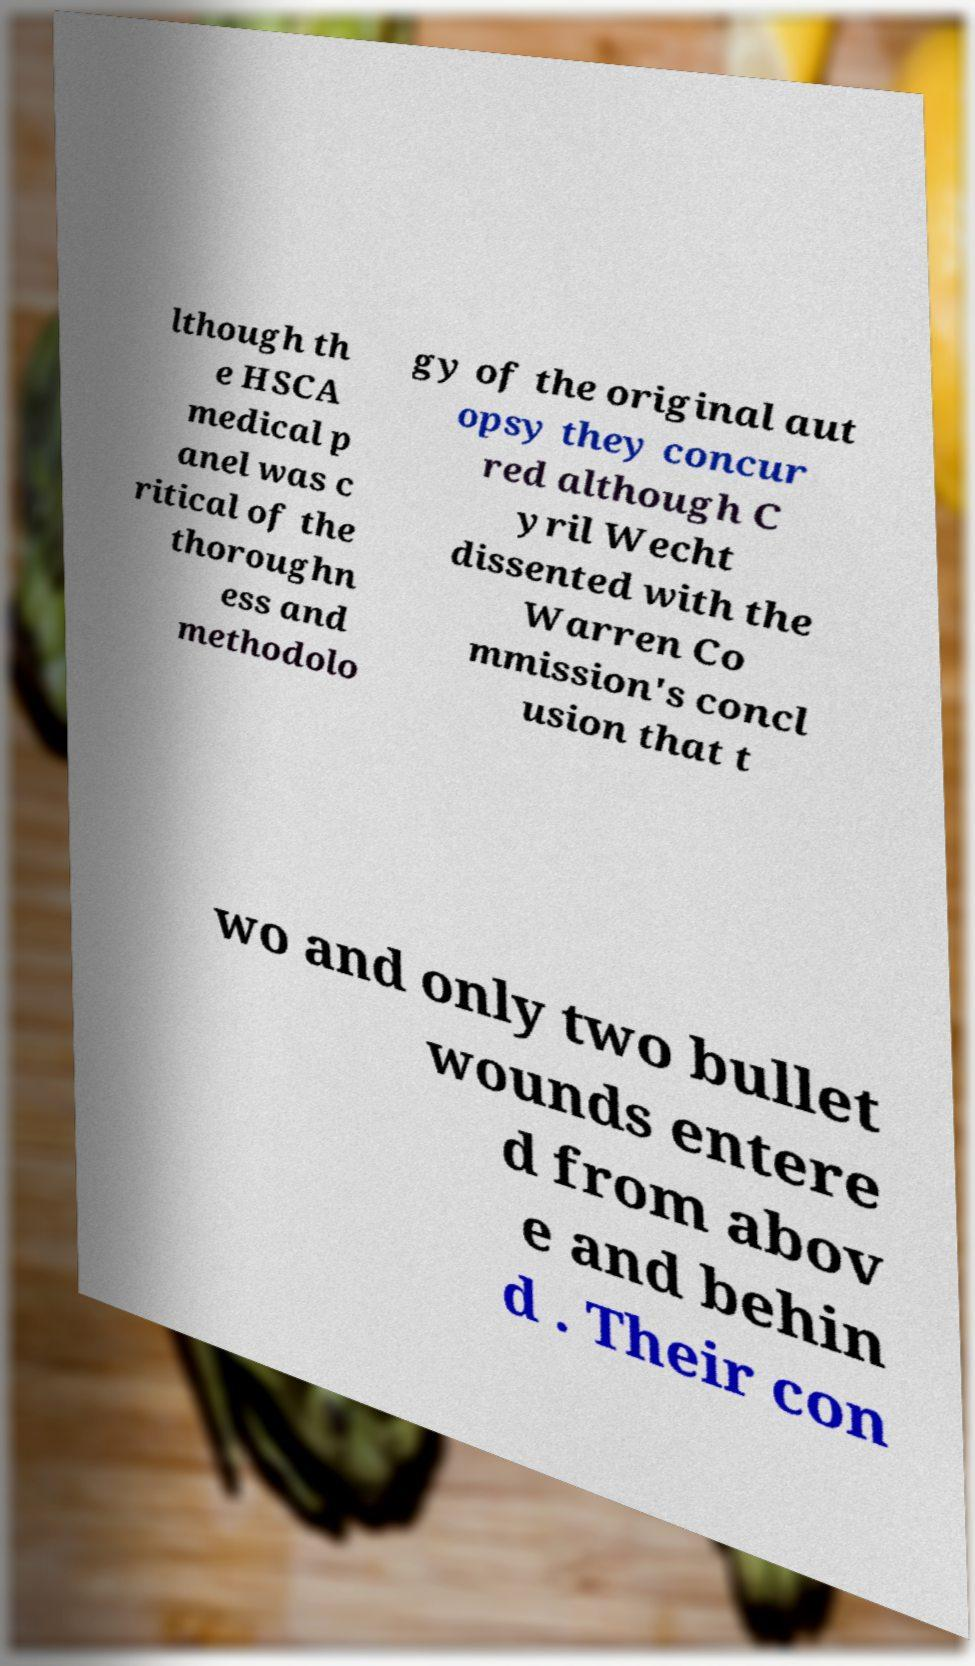What messages or text are displayed in this image? I need them in a readable, typed format. lthough th e HSCA medical p anel was c ritical of the thoroughn ess and methodolo gy of the original aut opsy they concur red although C yril Wecht dissented with the Warren Co mmission's concl usion that t wo and only two bullet wounds entere d from abov e and behin d . Their con 